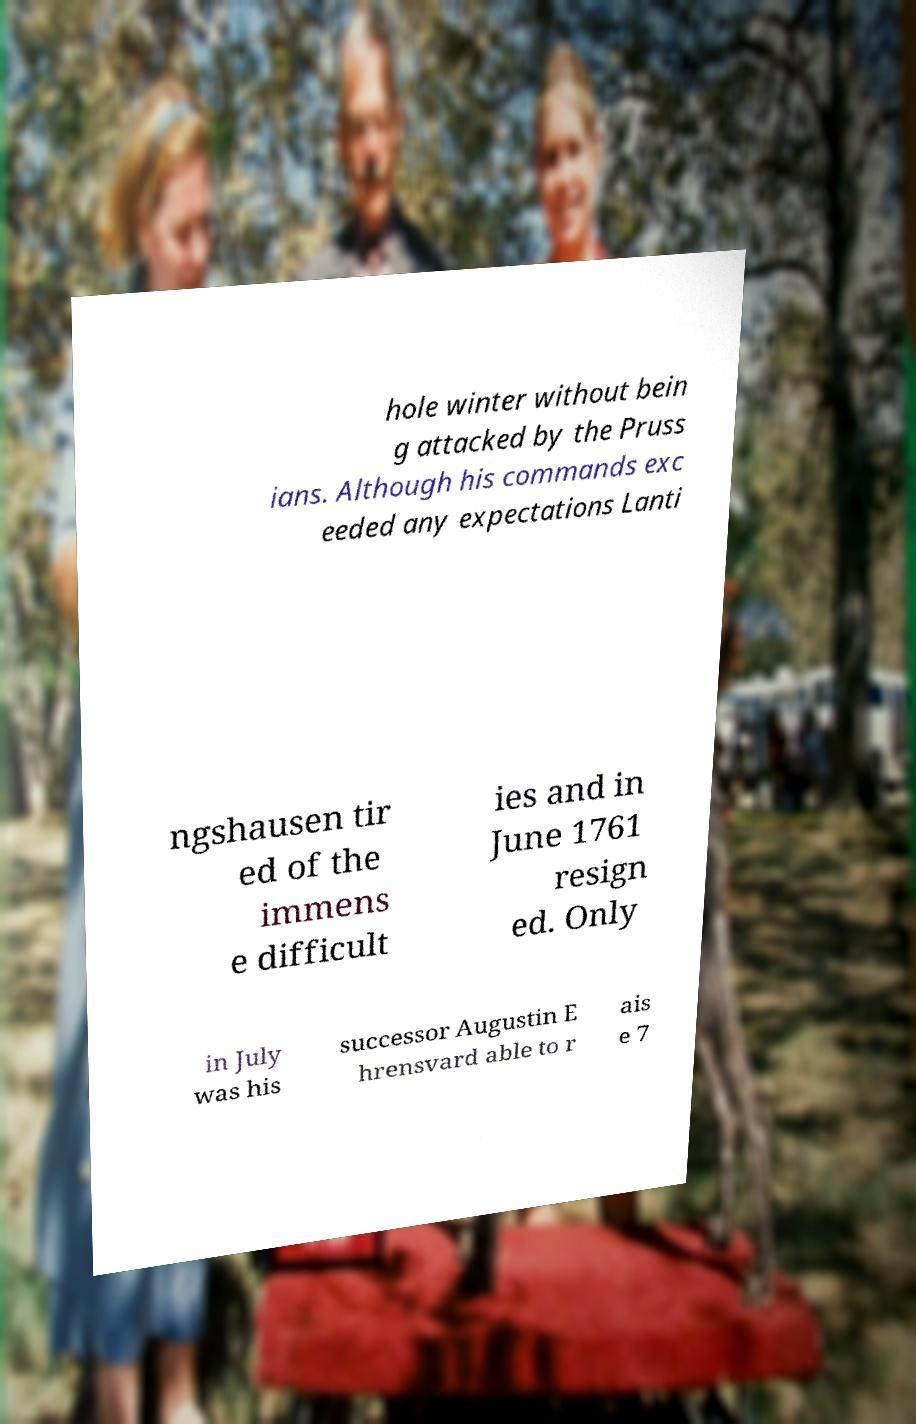There's text embedded in this image that I need extracted. Can you transcribe it verbatim? hole winter without bein g attacked by the Pruss ians. Although his commands exc eeded any expectations Lanti ngshausen tir ed of the immens e difficult ies and in June 1761 resign ed. Only in July was his successor Augustin E hrensvard able to r ais e 7 